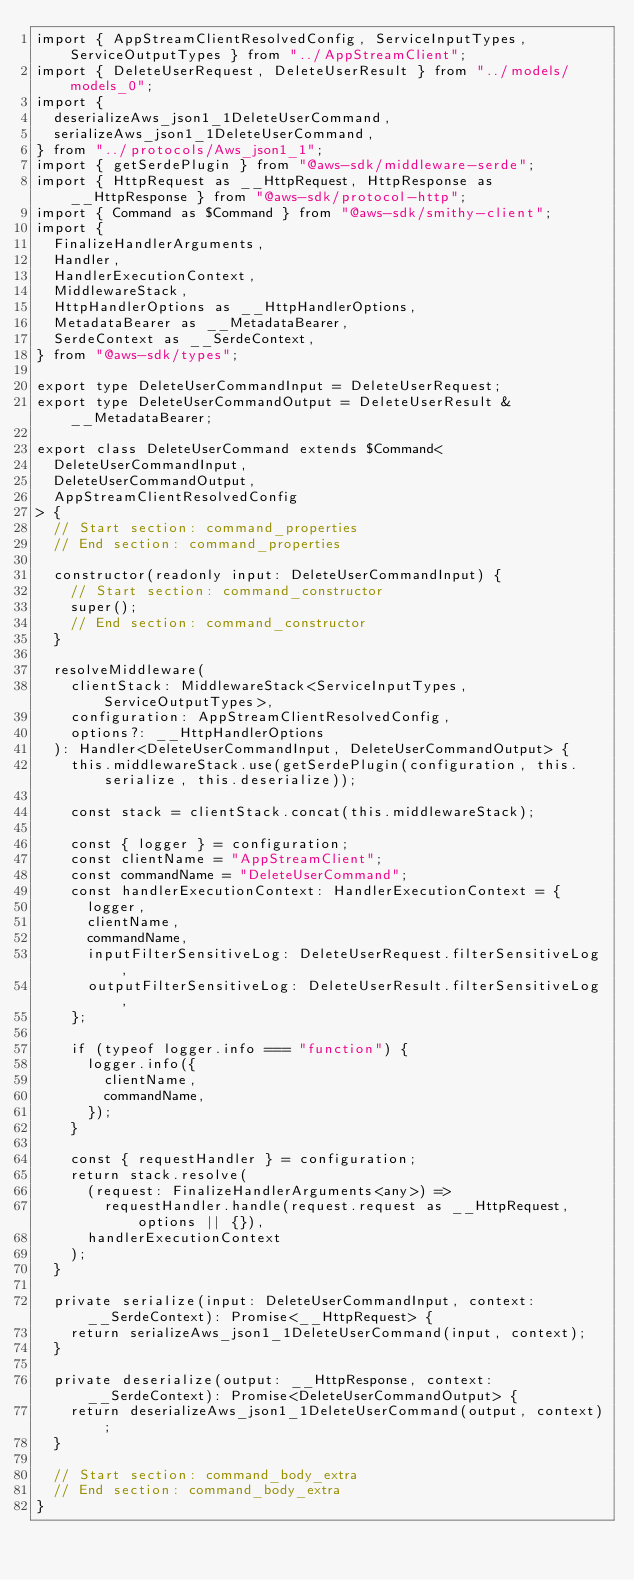<code> <loc_0><loc_0><loc_500><loc_500><_TypeScript_>import { AppStreamClientResolvedConfig, ServiceInputTypes, ServiceOutputTypes } from "../AppStreamClient";
import { DeleteUserRequest, DeleteUserResult } from "../models/models_0";
import {
  deserializeAws_json1_1DeleteUserCommand,
  serializeAws_json1_1DeleteUserCommand,
} from "../protocols/Aws_json1_1";
import { getSerdePlugin } from "@aws-sdk/middleware-serde";
import { HttpRequest as __HttpRequest, HttpResponse as __HttpResponse } from "@aws-sdk/protocol-http";
import { Command as $Command } from "@aws-sdk/smithy-client";
import {
  FinalizeHandlerArguments,
  Handler,
  HandlerExecutionContext,
  MiddlewareStack,
  HttpHandlerOptions as __HttpHandlerOptions,
  MetadataBearer as __MetadataBearer,
  SerdeContext as __SerdeContext,
} from "@aws-sdk/types";

export type DeleteUserCommandInput = DeleteUserRequest;
export type DeleteUserCommandOutput = DeleteUserResult & __MetadataBearer;

export class DeleteUserCommand extends $Command<
  DeleteUserCommandInput,
  DeleteUserCommandOutput,
  AppStreamClientResolvedConfig
> {
  // Start section: command_properties
  // End section: command_properties

  constructor(readonly input: DeleteUserCommandInput) {
    // Start section: command_constructor
    super();
    // End section: command_constructor
  }

  resolveMiddleware(
    clientStack: MiddlewareStack<ServiceInputTypes, ServiceOutputTypes>,
    configuration: AppStreamClientResolvedConfig,
    options?: __HttpHandlerOptions
  ): Handler<DeleteUserCommandInput, DeleteUserCommandOutput> {
    this.middlewareStack.use(getSerdePlugin(configuration, this.serialize, this.deserialize));

    const stack = clientStack.concat(this.middlewareStack);

    const { logger } = configuration;
    const clientName = "AppStreamClient";
    const commandName = "DeleteUserCommand";
    const handlerExecutionContext: HandlerExecutionContext = {
      logger,
      clientName,
      commandName,
      inputFilterSensitiveLog: DeleteUserRequest.filterSensitiveLog,
      outputFilterSensitiveLog: DeleteUserResult.filterSensitiveLog,
    };

    if (typeof logger.info === "function") {
      logger.info({
        clientName,
        commandName,
      });
    }

    const { requestHandler } = configuration;
    return stack.resolve(
      (request: FinalizeHandlerArguments<any>) =>
        requestHandler.handle(request.request as __HttpRequest, options || {}),
      handlerExecutionContext
    );
  }

  private serialize(input: DeleteUserCommandInput, context: __SerdeContext): Promise<__HttpRequest> {
    return serializeAws_json1_1DeleteUserCommand(input, context);
  }

  private deserialize(output: __HttpResponse, context: __SerdeContext): Promise<DeleteUserCommandOutput> {
    return deserializeAws_json1_1DeleteUserCommand(output, context);
  }

  // Start section: command_body_extra
  // End section: command_body_extra
}
</code> 